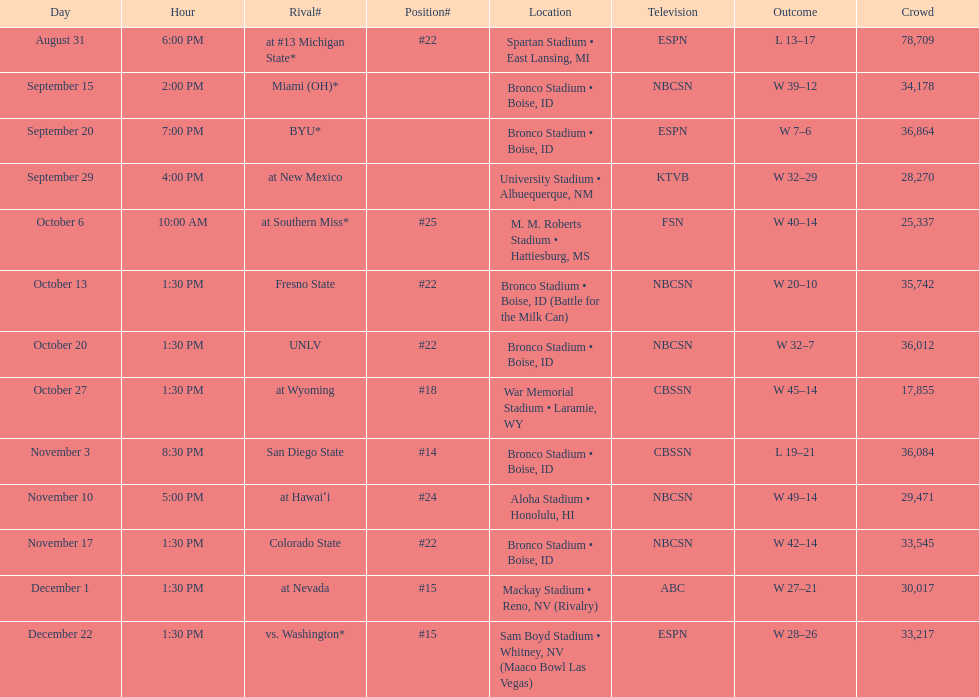What was the most consecutive wins for the team shown in the season? 7. 